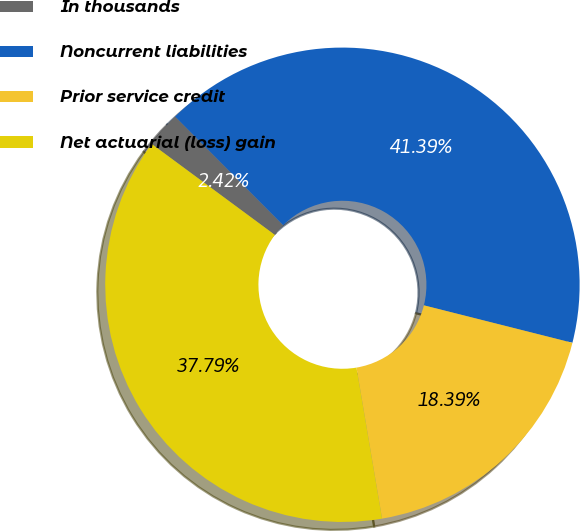<chart> <loc_0><loc_0><loc_500><loc_500><pie_chart><fcel>In thousands<fcel>Noncurrent liabilities<fcel>Prior service credit<fcel>Net actuarial (loss) gain<nl><fcel>2.42%<fcel>41.39%<fcel>18.39%<fcel>37.79%<nl></chart> 